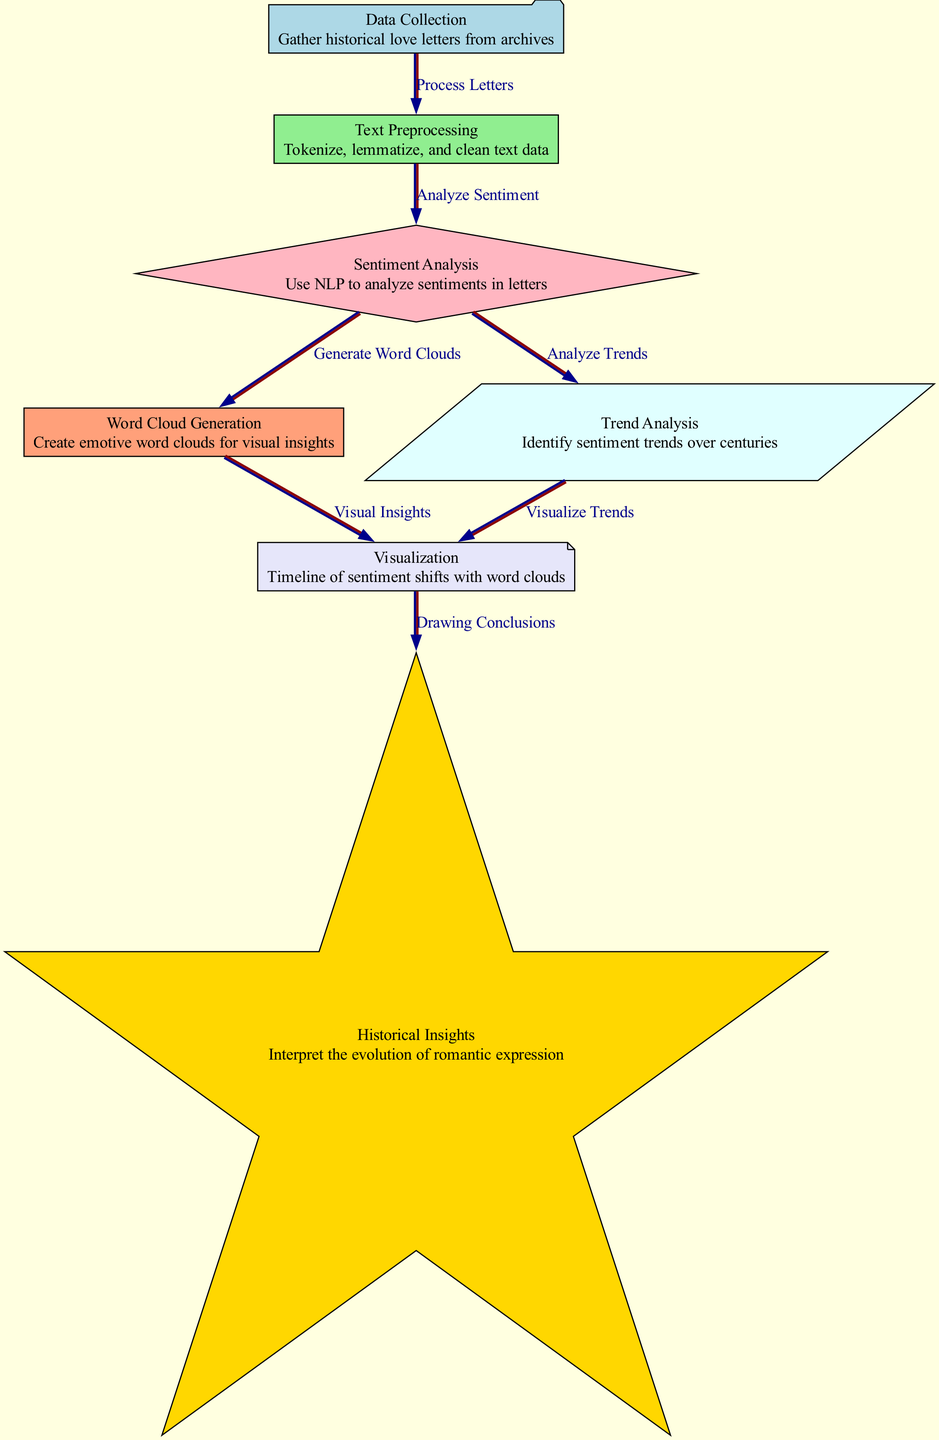What is the first step in the diagram? The diagram starts with "Data Collection," which indicates the initial phase of gathering historical love letters from archives.
Answer: Data Collection How many edges are there in the diagram? By counting the connections between nodes, there are a total of six edges depicted that link various processes together.
Answer: 6 What follows "Text Preprocessing" in the diagram? The flow moves from "Text Preprocessing" to "Sentiment Analysis," indicating that after cleaning and tokenizing the text, the next step is to analyze the sentiments in the letters.
Answer: Sentiment Analysis Which node is related to creating visual insights? "Word Cloud Generation" connects to "Visualization," which signifies that the generation of emotive word clouds is necessary to achieve visual insights in the diagram.
Answer: Word Cloud Generation Which node culminates the process by interpreting the results? The final node in the flow is "Historical Insights," which represents the conclusive stage where the evolution of romantic expression is interpreted based on previous analyses.
Answer: Historical Insights How do "Sentiment Analysis" and "Word Cloud Generation" relate? Both nodes are linked by an edge leading from "Sentiment Analysis" to "Word Cloud Generation," indicating that the analysis of sentiments directly informs the generation of word clouds.
Answer: Analyze Sentiment What is the shape of the "Data Collection" node? The shape of the "Data Collection" node is styled as a folder, visually communicating its purpose of storing or gathering data.
Answer: Folder What type of insights does the "Visualization" node provide? The "Visualization" node provides insights into sentiment shifts over time by visually representing trends alongside emotive word clouds.
Answer: Visual Insights 